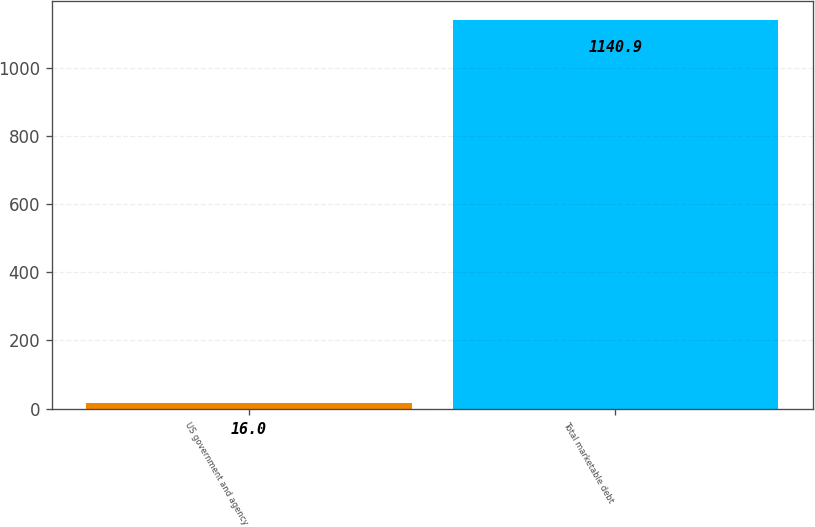Convert chart. <chart><loc_0><loc_0><loc_500><loc_500><bar_chart><fcel>US government and agency<fcel>Total marketable debt<nl><fcel>16<fcel>1140.9<nl></chart> 